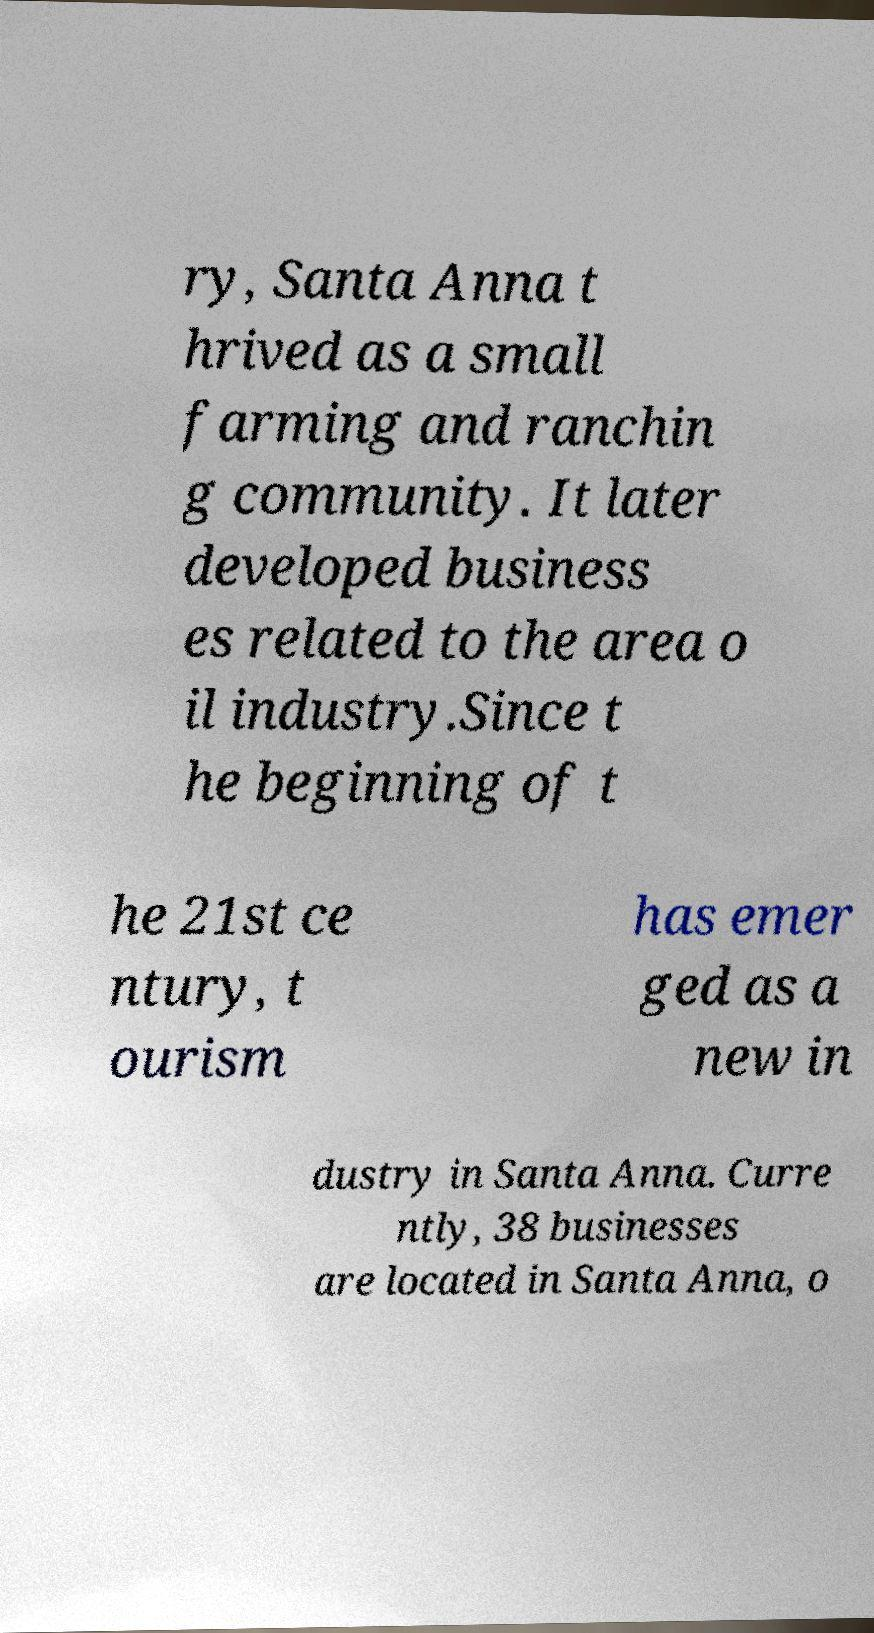Can you read and provide the text displayed in the image?This photo seems to have some interesting text. Can you extract and type it out for me? ry, Santa Anna t hrived as a small farming and ranchin g community. It later developed business es related to the area o il industry.Since t he beginning of t he 21st ce ntury, t ourism has emer ged as a new in dustry in Santa Anna. Curre ntly, 38 businesses are located in Santa Anna, o 